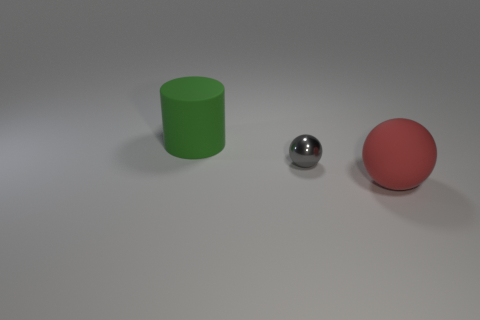Subtract 1 red balls. How many objects are left? 2 Subtract all balls. How many objects are left? 1 Subtract all brown spheres. Subtract all green cylinders. How many spheres are left? 2 Subtract all brown cylinders. How many gray balls are left? 1 Subtract all big matte spheres. Subtract all tiny cyan rubber balls. How many objects are left? 2 Add 3 cylinders. How many cylinders are left? 4 Add 2 large green rubber things. How many large green rubber things exist? 3 Add 3 large green matte cylinders. How many objects exist? 6 Subtract all gray balls. How many balls are left? 1 